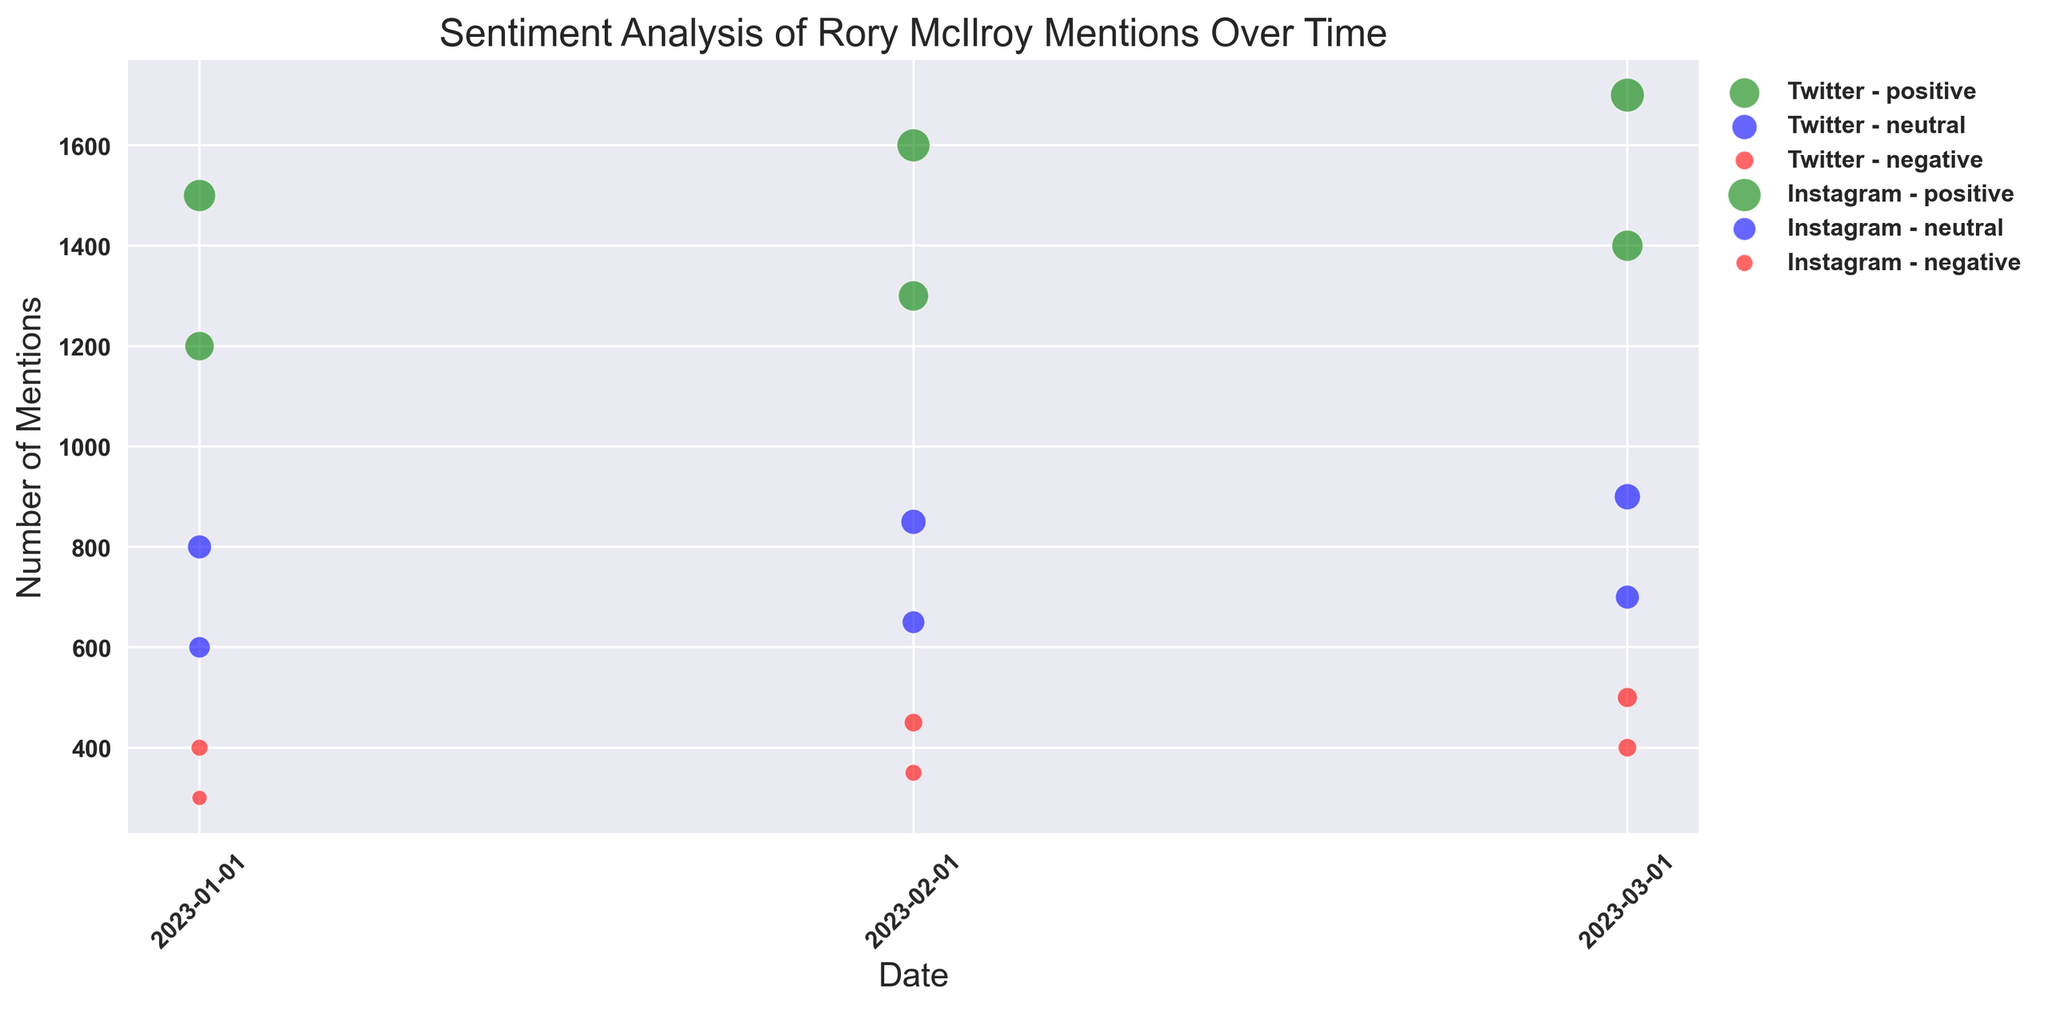What sentiment has the largest bubble size on Instagram on January 1, 2023? To find the largest bubble size on Instagram on January 1, 2023, look at the data points for Instagram on that date. The largest bubble size corresponds to positive sentiment.
Answer: Positive How did the number of positive mentions on Twitter change from January to February? Look at the points labeled for Twitter with positive sentiment in January and February. The number of positive mentions increased from 1200 in January to 1300 in February.
Answer: Increased Which platform has more negative mentions in March 2023? Compare the number of negative mentions between Twitter and Instagram in March 2023. Instagram has 400 negative mentions, while Twitter has 500.
Answer: Twitter For February 2023, which sentiment had the smallest bubble size on Instagram? Check the Instagram data points for February 2023. The sentiment with the smallest bubble size is negative.
Answer: Negative Across all three months, on which platform did positive sentiment consistently have the highest number of mentions? Analyze the positive sentiment across January, February, and March for both platforms. Instagram consistently has higher positive mentions each month.
Answer: Instagram In March 2023, which sentiment on Twitter had the largest number of mentions? Review Twitter's data points for March 2023. The sentiment with the largest number of mentions is positive, with 1400 mentions.
Answer: Positive What is the difference in the number of neutral mentions between Twitter and Instagram on March 1, 2023? For March 1, 2023, Twitter has 900 neutral mentions, and Instagram has 700. The difference is 900 - 700 = 200.
Answer: 200 Which sentiment showed the least variability in the number of mentions over the three months for Instagram? Analyze the variations in numbers of mentions across the months for each sentiment on Instagram. Neutral sentiment shows relatively small changes: 600 in January, 650 in February, and 700 in March.
Answer: Neutral Comparing January and March, which month had the highest number of positive mentions on Instagram? Compare the number of positive mentions on Instagram in January and March. March has 1700 mentions compared to 1500 in January.
Answer: March 